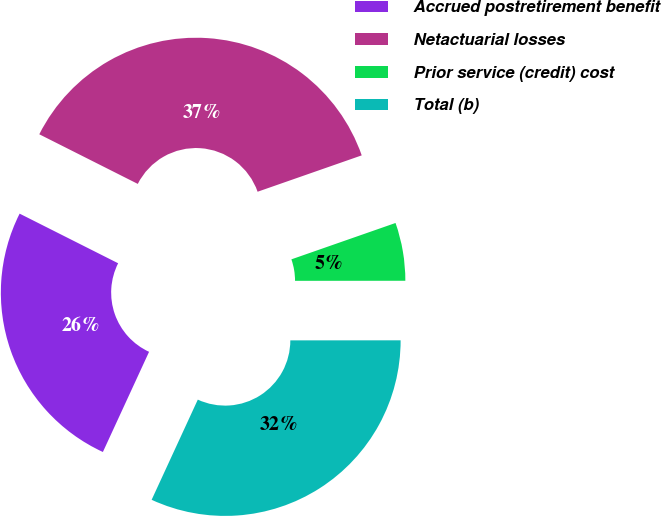Convert chart. <chart><loc_0><loc_0><loc_500><loc_500><pie_chart><fcel>Accrued postretirement benefit<fcel>Netactuarial losses<fcel>Prior service (credit) cost<fcel>Total (b)<nl><fcel>25.55%<fcel>37.22%<fcel>5.34%<fcel>31.88%<nl></chart> 